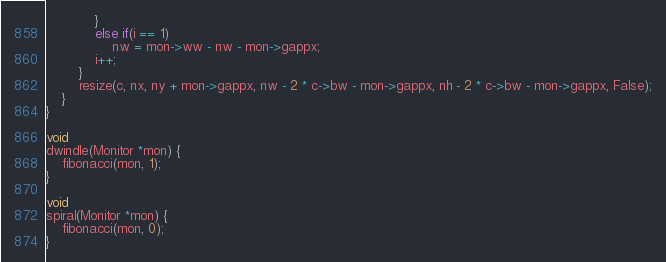<code> <loc_0><loc_0><loc_500><loc_500><_C_>			}
			else if(i == 1)
				nw = mon->ww - nw - mon->gappx;
			i++;
		}
		resize(c, nx, ny + mon->gappx, nw - 2 * c->bw - mon->gappx, nh - 2 * c->bw - mon->gappx, False);
	}
}

void
dwindle(Monitor *mon) {
	fibonacci(mon, 1);
}

void
spiral(Monitor *mon) {
	fibonacci(mon, 0);
}

</code> 